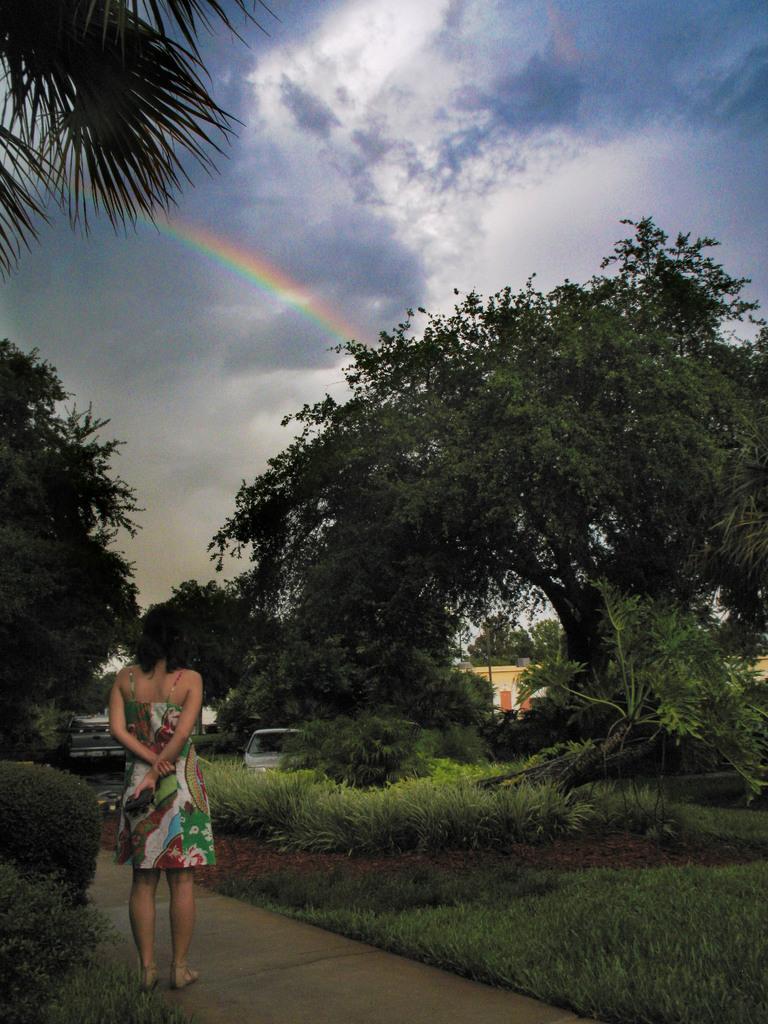Please provide a concise description of this image. In this picture we can see a woman standing on a path, trees, vehicles, building and in the background we can see the sky with clouds. 